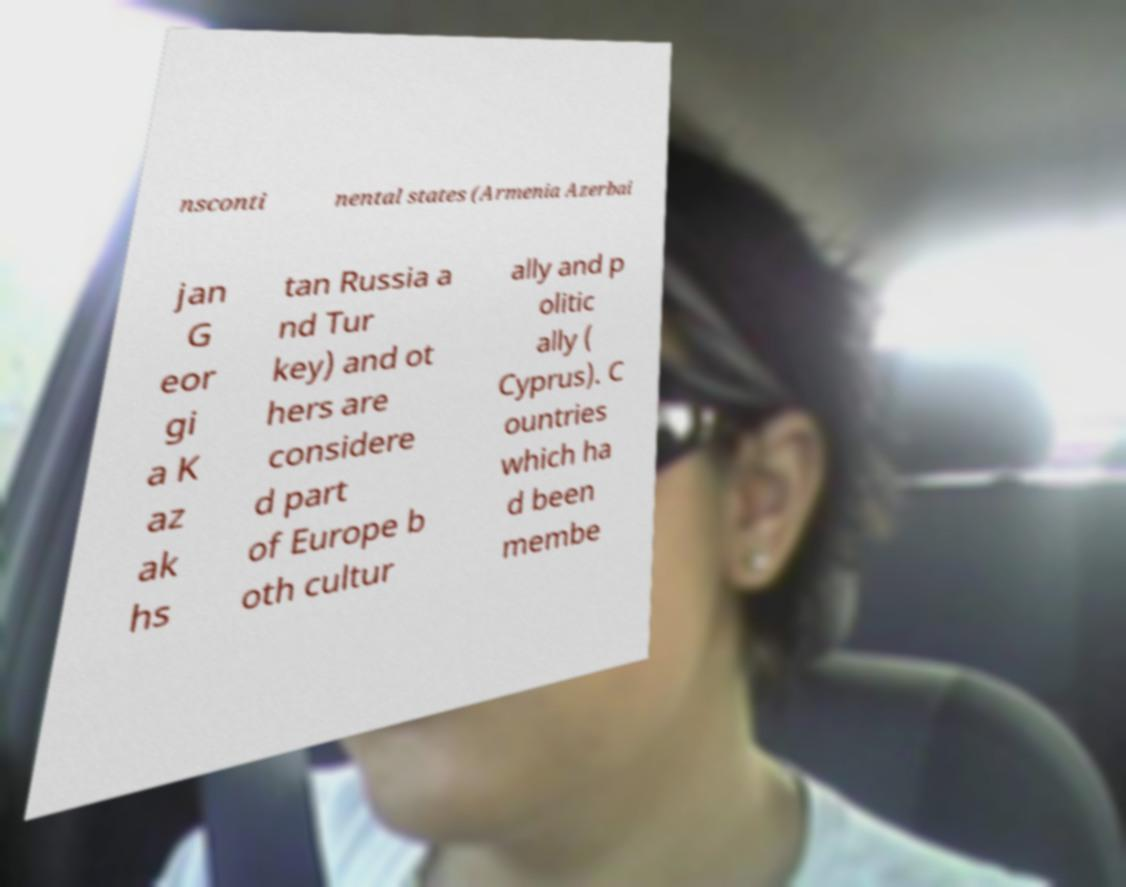Could you assist in decoding the text presented in this image and type it out clearly? nsconti nental states (Armenia Azerbai jan G eor gi a K az ak hs tan Russia a nd Tur key) and ot hers are considere d part of Europe b oth cultur ally and p olitic ally ( Cyprus). C ountries which ha d been membe 